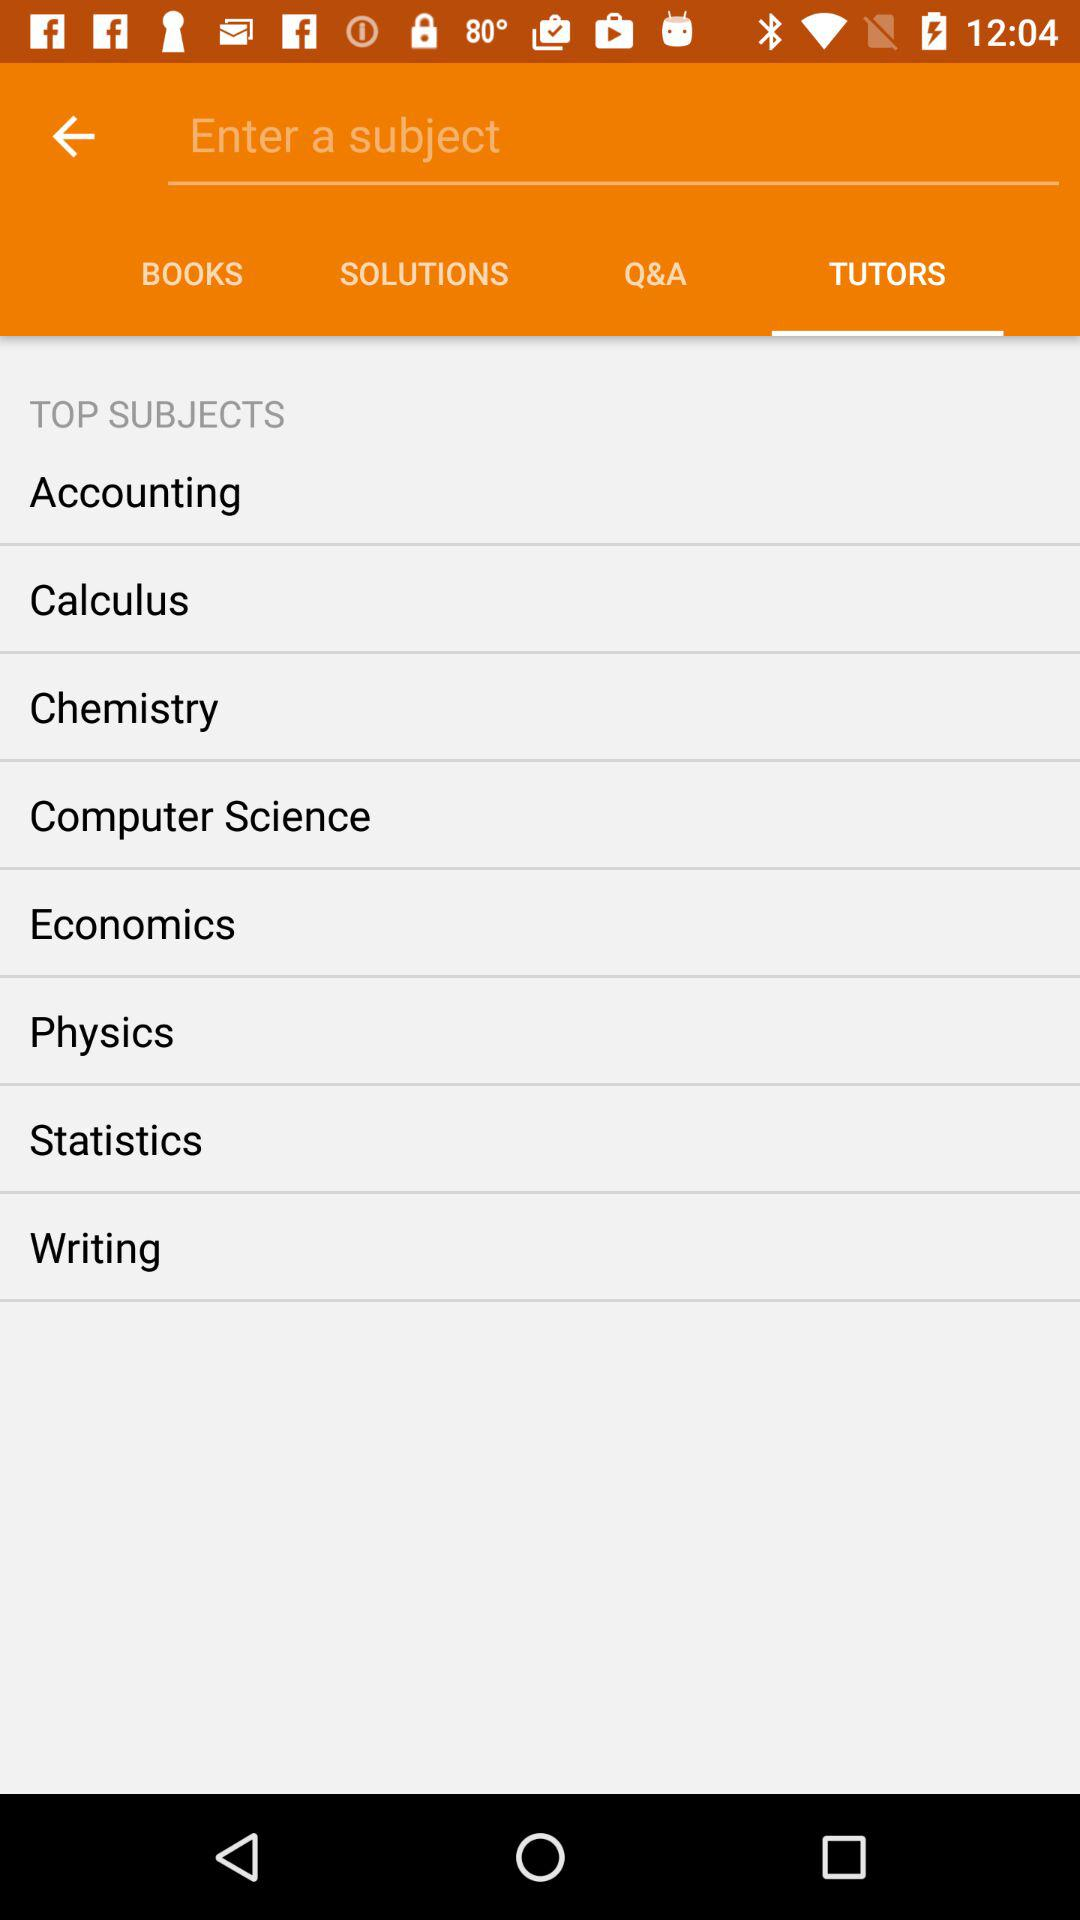What are the top subjects? The top subjects are "Accounting", "Calculus", "Chemistry", "Computer Science", "Economics", "Physics", "Statistics" and "Writing". 